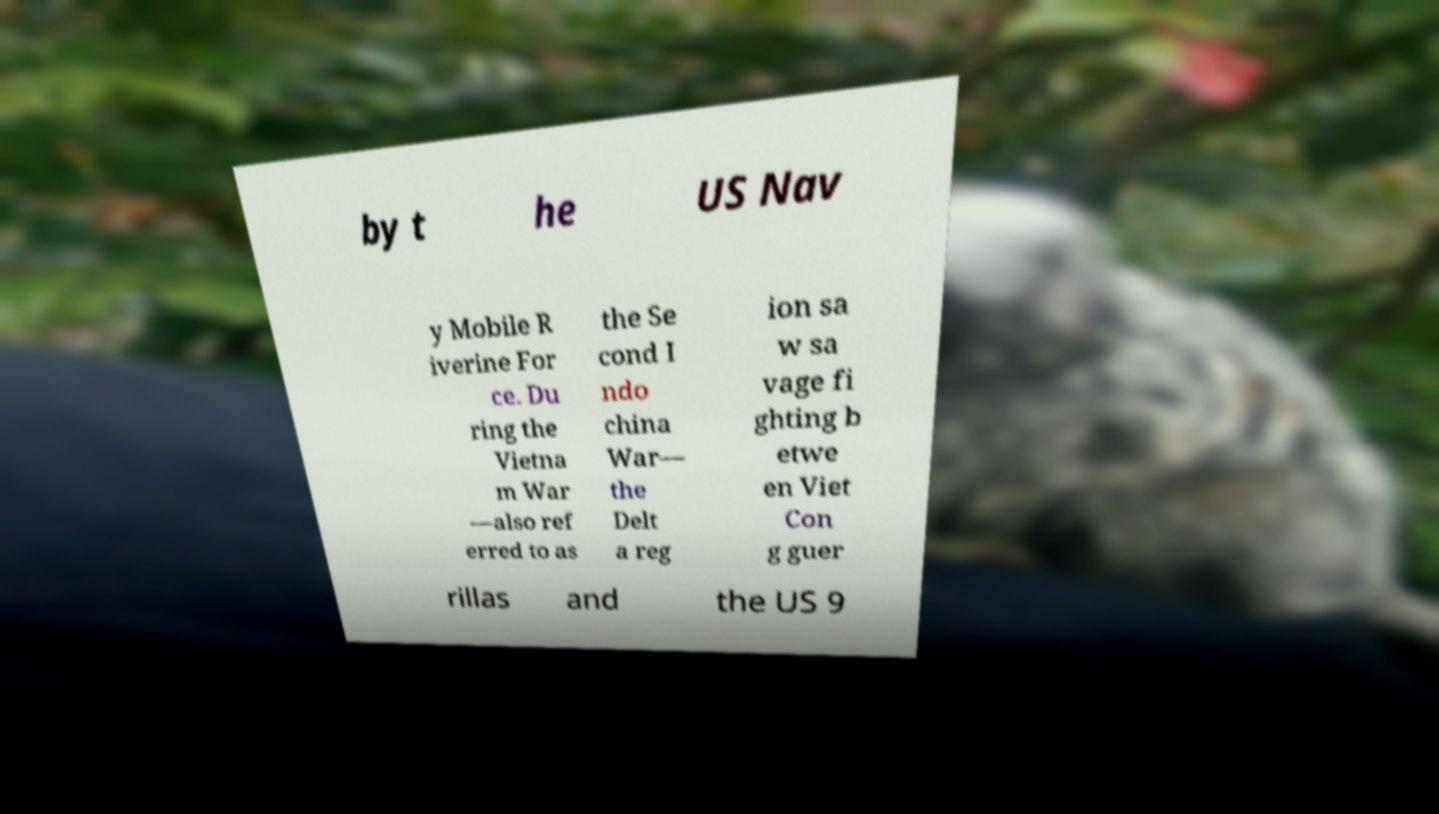Could you extract and type out the text from this image? by t he US Nav y Mobile R iverine For ce. Du ring the Vietna m War —also ref erred to as the Se cond I ndo china War— the Delt a reg ion sa w sa vage fi ghting b etwe en Viet Con g guer rillas and the US 9 